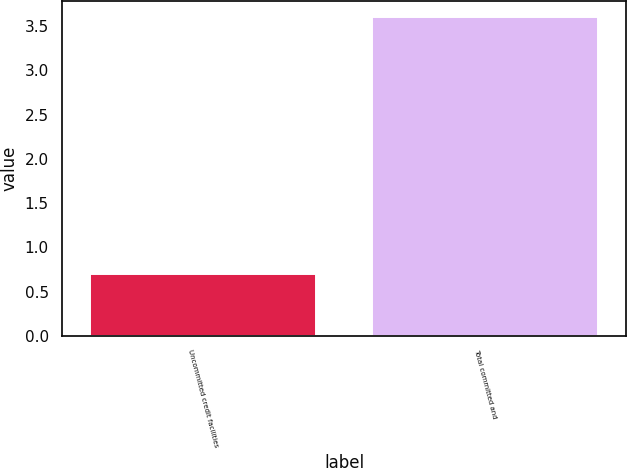<chart> <loc_0><loc_0><loc_500><loc_500><bar_chart><fcel>Uncommitted credit facilities<fcel>Total committed and<nl><fcel>0.7<fcel>3.6<nl></chart> 